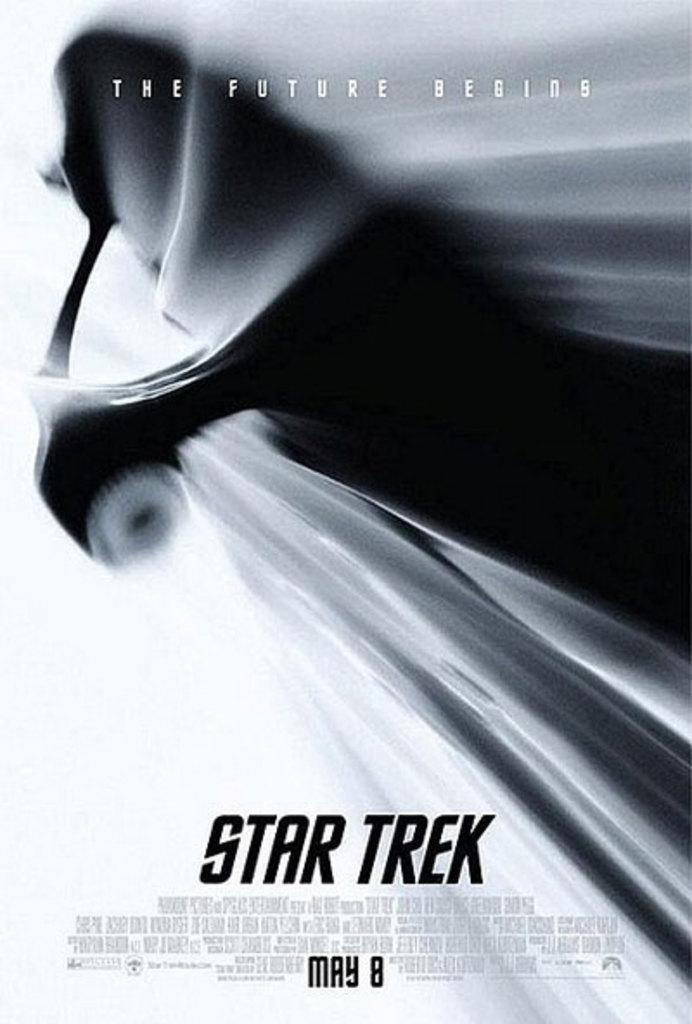What is present in the image that features text and colors? There is a poster in the image. What colors are used on the poster? The poster has black, gray, and white colors. How has the text on the poster been modified? The text on the poster has been edited. Can you see a point on the poster where a rat is riding a boat? There is no point on the poster where a rat is riding a boat; the image does not depict any rats or boats. 